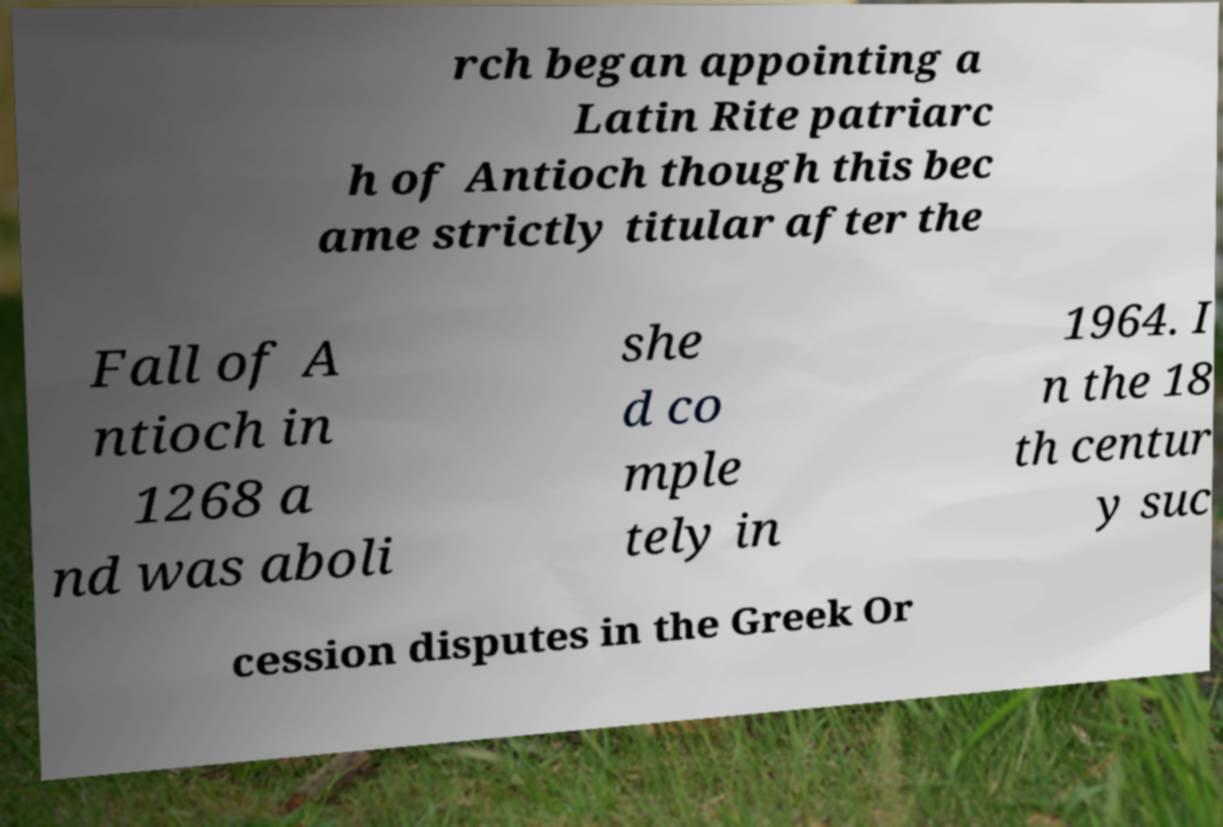For documentation purposes, I need the text within this image transcribed. Could you provide that? rch began appointing a Latin Rite patriarc h of Antioch though this bec ame strictly titular after the Fall of A ntioch in 1268 a nd was aboli she d co mple tely in 1964. I n the 18 th centur y suc cession disputes in the Greek Or 